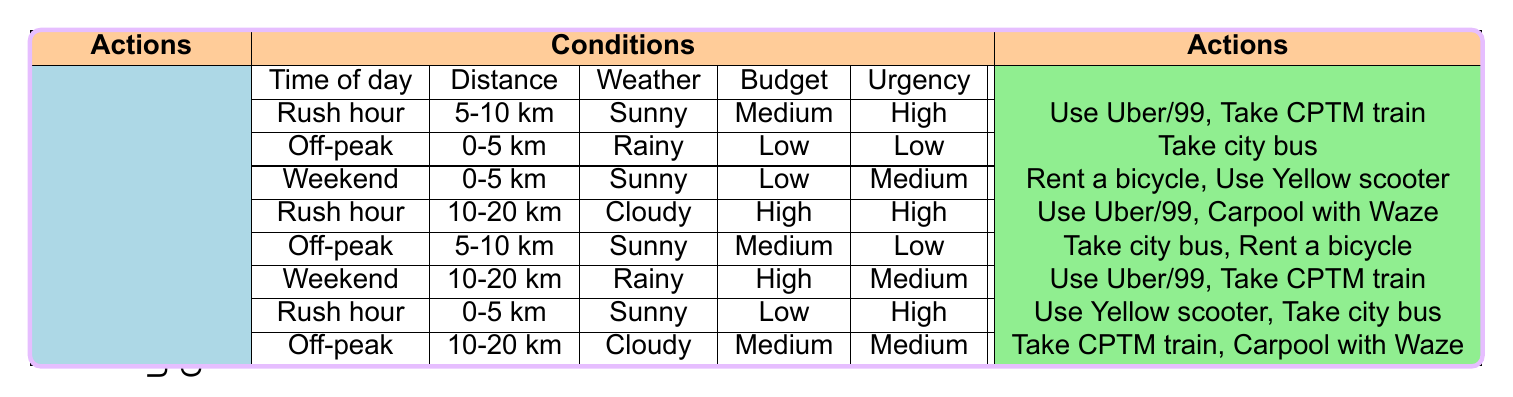What transportation option is suggested during rush hour with a distance of 0-5 km and sunny weather? According to the table, for the condition of rush hour, 0-5 km distance, and sunny weather, the transportation options are "Use Yellow scooter" and "Take city bus."
Answer: Use Yellow scooter, Take city bus Is it true that "taking a city bus" is an option during off-peak times with any budget? Looking at the table, taking a city bus is an option during off-peak for a distance of 0-5 km and rainy weather with a low budget, and also for 5-10 km and sunny weather with a medium budget. Therefore, it's not applicable for all budgets.
Answer: No What are the possible transport options on the weekend for distances between 0-5 km? The table shows that on the weekend with a distance of 0-5 km and sunny weather, the options are "Rent a bicycle" and "Use Yellow scooter."
Answer: Rent a bicycle, Use Yellow scooter During rush hour, what combination of distance and weather allows the use of Uber/99? Based on the table, Uber/99 can be used during rush hour if the distance is 5-10 km with sunny weather and also for 10-20 km with cloudy weather. This requires checking both conditions.
Answer: 5-10 km sunny, 10-20 km cloudy What is the most viable option in terms of transportation when budget is high, distance is 10-20 km, and the weather is rainy? The table indicates that under these conditions, which are weekend, high budget, 10-20 km distance, and rainy weather, the transport options are "Use Uber/99" and "Take CPTM train."
Answer: Use Uber/99, Take CPTM train 